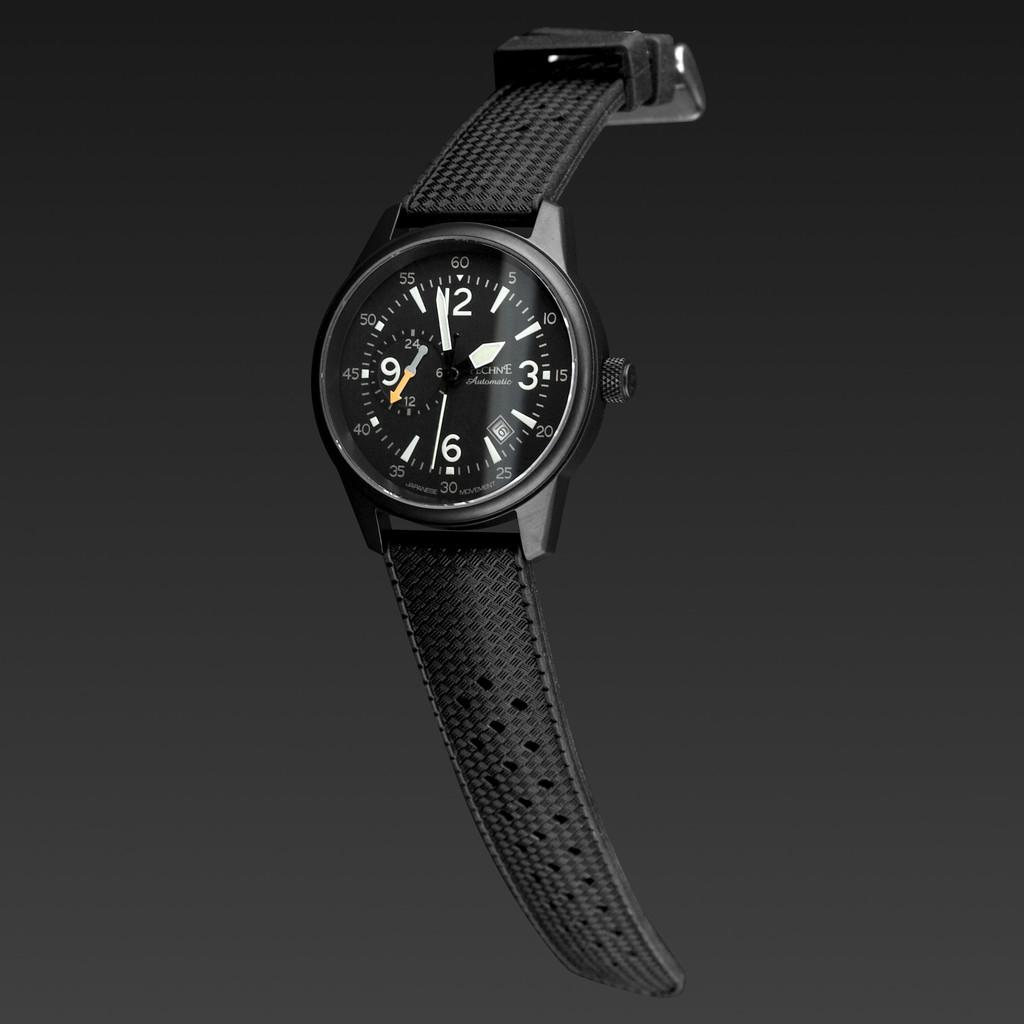Provide a one-sentence caption for the provided image. A watch made by Pechne says that today is the 16th. 